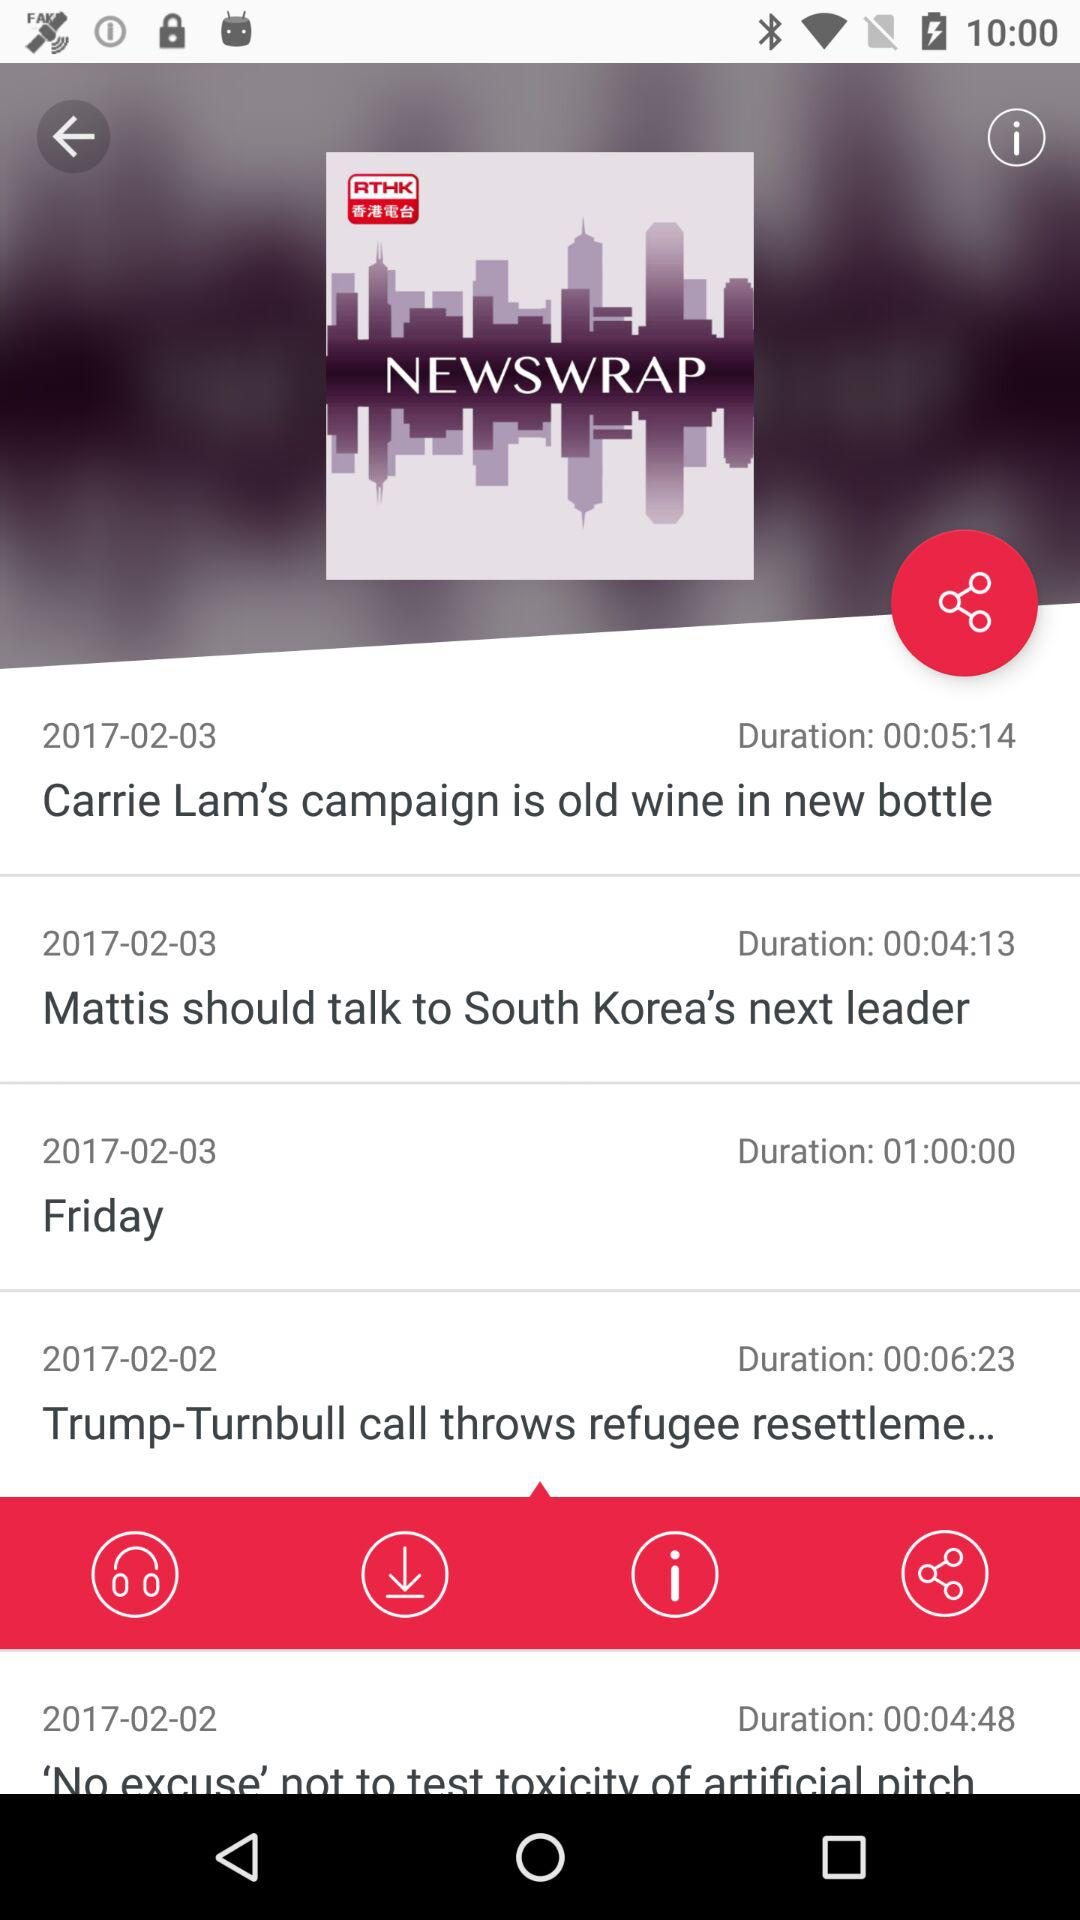On which date was the news "Carrie Lam's campaign is old wine in new bottle" published? The news was "Carrie Lam's campaign is old wine in new bottle" published on February 3, 2017. 